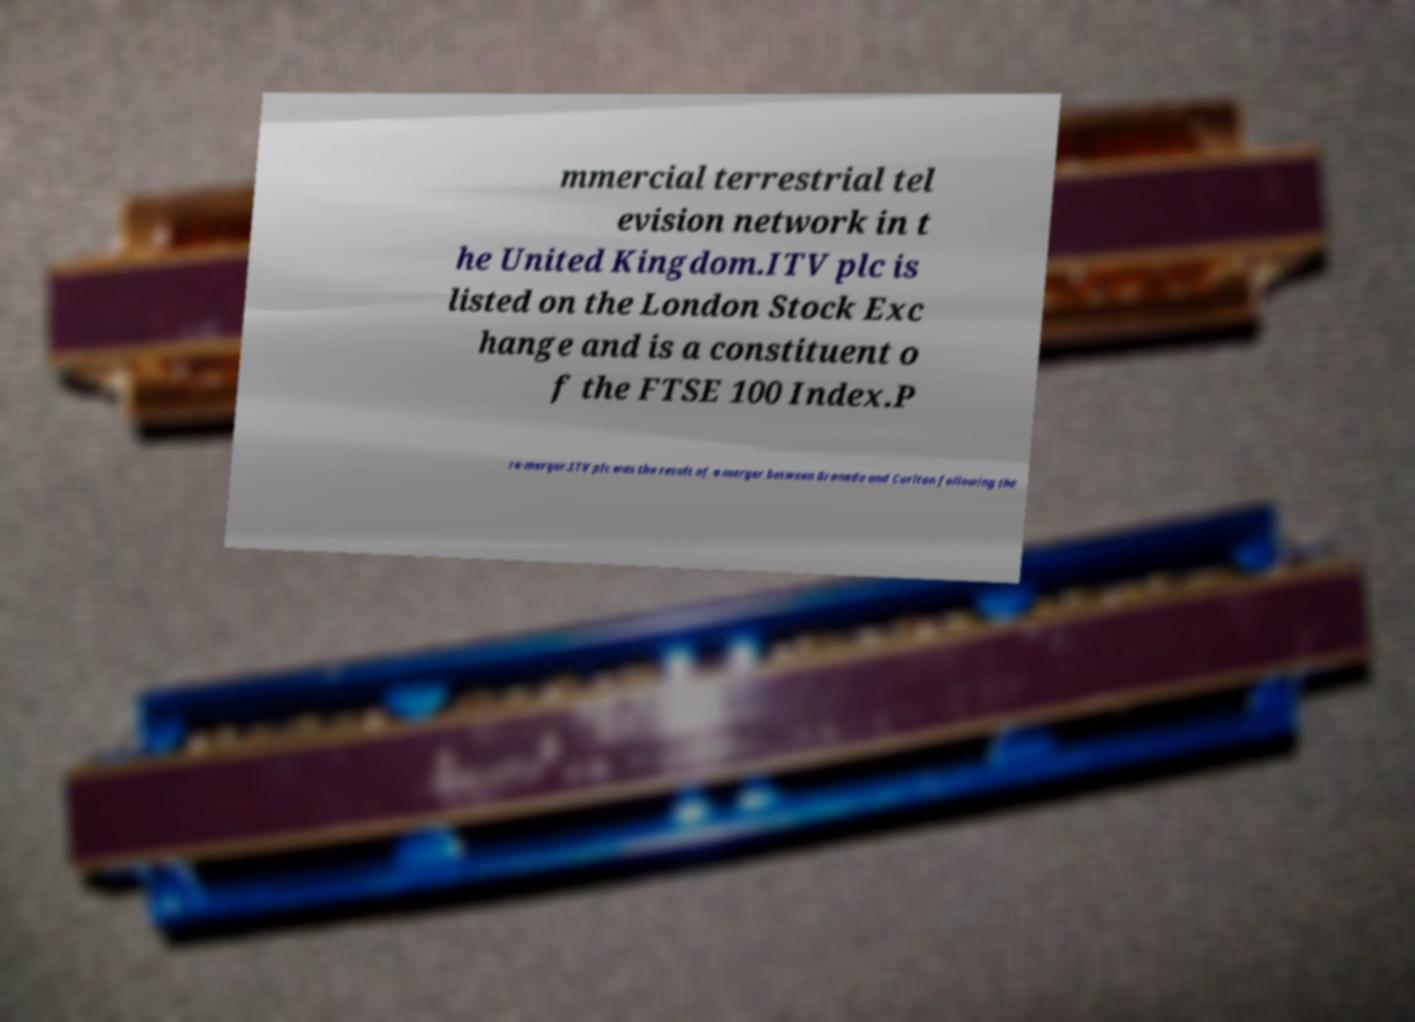Can you accurately transcribe the text from the provided image for me? mmercial terrestrial tel evision network in t he United Kingdom.ITV plc is listed on the London Stock Exc hange and is a constituent o f the FTSE 100 Index.P re-merger.ITV plc was the result of a merger between Granada and Carlton following the 